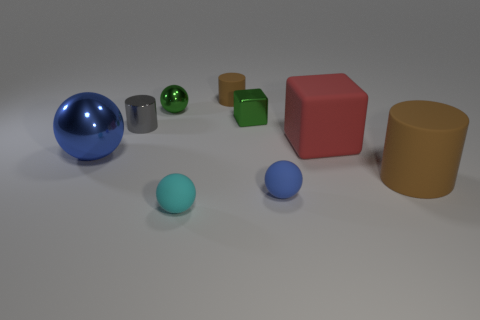The object that is the same color as the small matte cylinder is what size?
Make the answer very short. Large. There is a large object on the left side of the gray cylinder; does it have the same shape as the blue object to the right of the small green shiny ball?
Provide a short and direct response. Yes. Are there any cyan balls of the same size as the cyan object?
Keep it short and to the point. No. Is the number of tiny rubber things that are to the left of the red matte block the same as the number of red rubber cubes to the left of the cyan matte ball?
Keep it short and to the point. No. Is the blue ball in front of the big blue thing made of the same material as the blue object on the left side of the cyan ball?
Offer a very short reply. No. What is the large sphere made of?
Make the answer very short. Metal. How many other objects are there of the same color as the matte cube?
Make the answer very short. 0. Is the color of the large sphere the same as the tiny metallic ball?
Your answer should be compact. No. How many large blue spheres are there?
Provide a short and direct response. 1. The tiny blue sphere that is behind the rubber thing left of the tiny brown matte cylinder is made of what material?
Your answer should be compact. Rubber. 